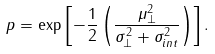Convert formula to latex. <formula><loc_0><loc_0><loc_500><loc_500>p = \exp \left [ - \frac { 1 } { 2 } \left ( \frac { \mu _ { \perp } ^ { 2 } } { \sigma _ { \perp } ^ { 2 } + \sigma _ { i n t } ^ { 2 } } \right ) \right ] .</formula> 